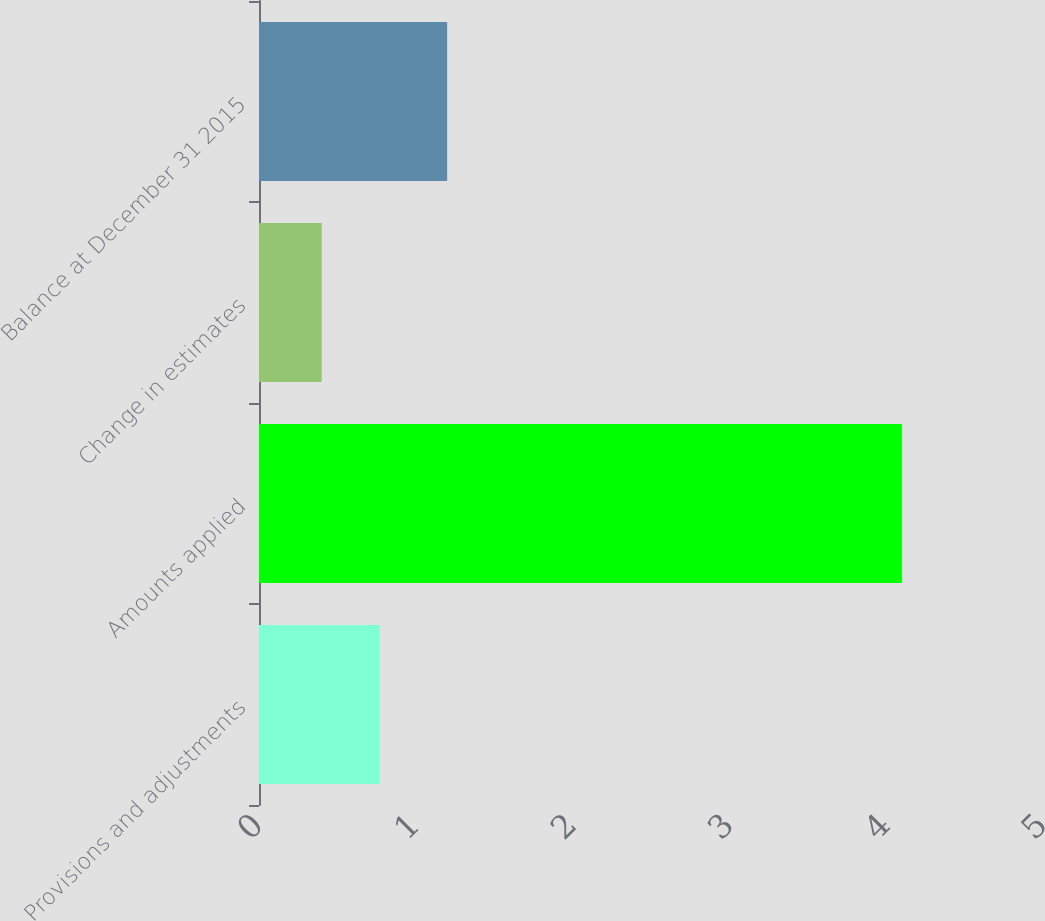Convert chart to OTSL. <chart><loc_0><loc_0><loc_500><loc_500><bar_chart><fcel>Provisions and adjustments<fcel>Amounts applied<fcel>Change in estimates<fcel>Balance at December 31 2015<nl><fcel>0.77<fcel>4.1<fcel>0.4<fcel>1.2<nl></chart> 